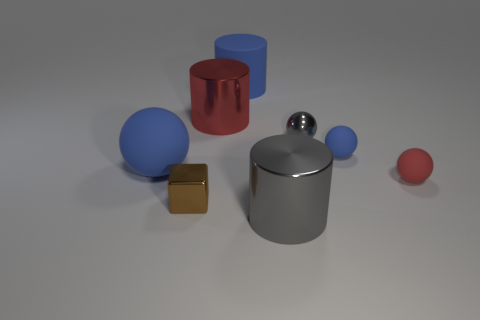Is the shape of the tiny red matte object the same as the small blue rubber thing?
Provide a succinct answer. Yes. Are there more tiny red matte things that are in front of the big rubber ball than big matte cylinders in front of the large red metal cylinder?
Your response must be concise. Yes. There is a blue sphere left of the tiny brown shiny object; what number of tiny things are behind it?
Make the answer very short. 2. There is a large gray object on the right side of the large matte sphere; is it the same shape as the large red object?
Keep it short and to the point. Yes. What is the material of the tiny red object that is the same shape as the small gray shiny thing?
Give a very brief answer. Rubber. What number of blue objects are the same size as the blue cylinder?
Ensure brevity in your answer.  1. There is a tiny thing that is both behind the small shiny cube and to the left of the small blue sphere; what color is it?
Offer a terse response. Gray. Are there fewer tiny brown metallic blocks than large cyan blocks?
Ensure brevity in your answer.  No. There is a matte cylinder; does it have the same color as the sphere to the left of the small gray sphere?
Ensure brevity in your answer.  Yes. Are there the same number of small red rubber balls that are in front of the red metal cylinder and gray cylinders that are behind the brown object?
Offer a terse response. No. 